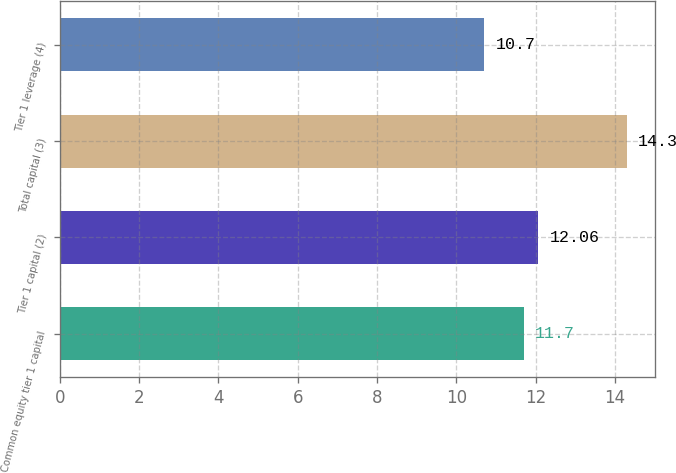Convert chart to OTSL. <chart><loc_0><loc_0><loc_500><loc_500><bar_chart><fcel>Common equity tier 1 capital<fcel>Tier 1 capital (2)<fcel>Total capital (3)<fcel>Tier 1 leverage (4)<nl><fcel>11.7<fcel>12.06<fcel>14.3<fcel>10.7<nl></chart> 